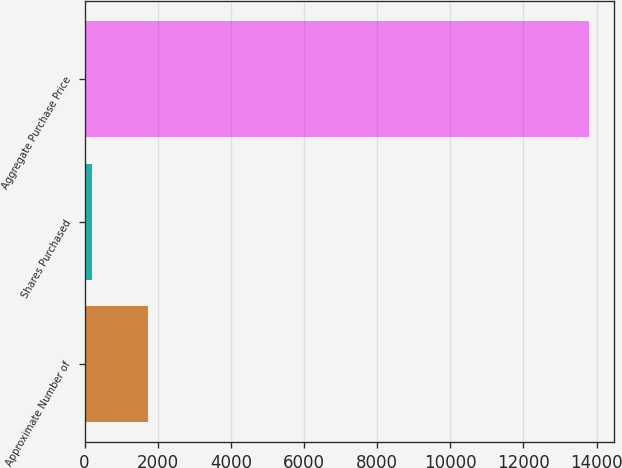<chart> <loc_0><loc_0><loc_500><loc_500><bar_chart><fcel>Approximate Number of<fcel>Shares Purchased<fcel>Aggregate Purchase Price<nl><fcel>1746<fcel>212<fcel>13787<nl></chart> 